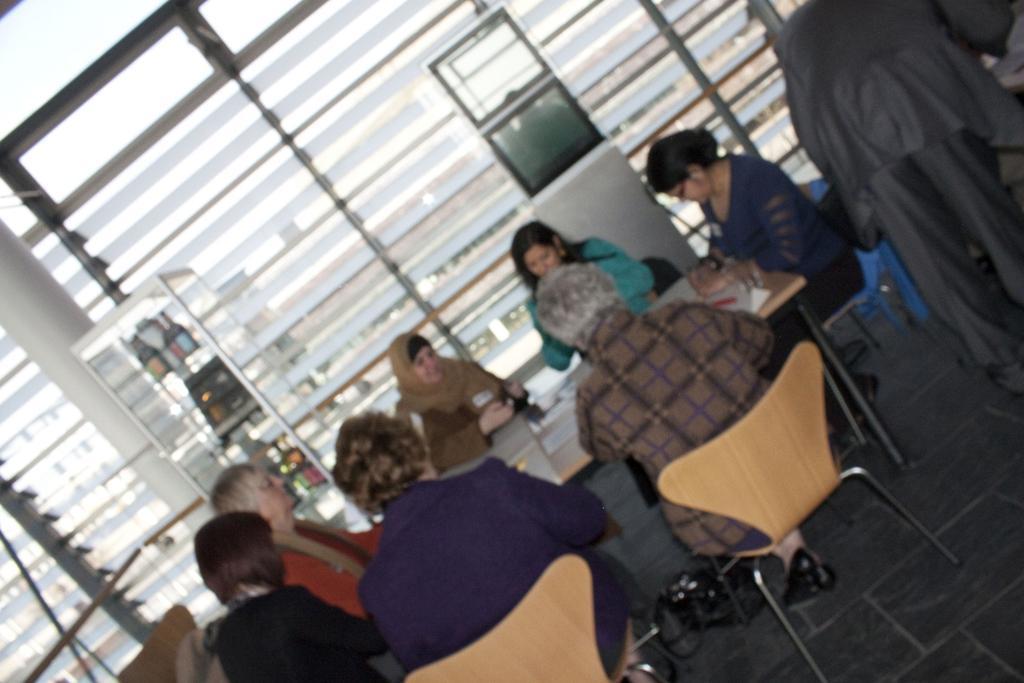Can you describe this image briefly? In this image, we can see a group of people wearing clothes and sitting on chairs in front of the table. There is a rack and pillar on the left side of the image. There is window in the middle of the image. There is an another person in the top right of the image. 